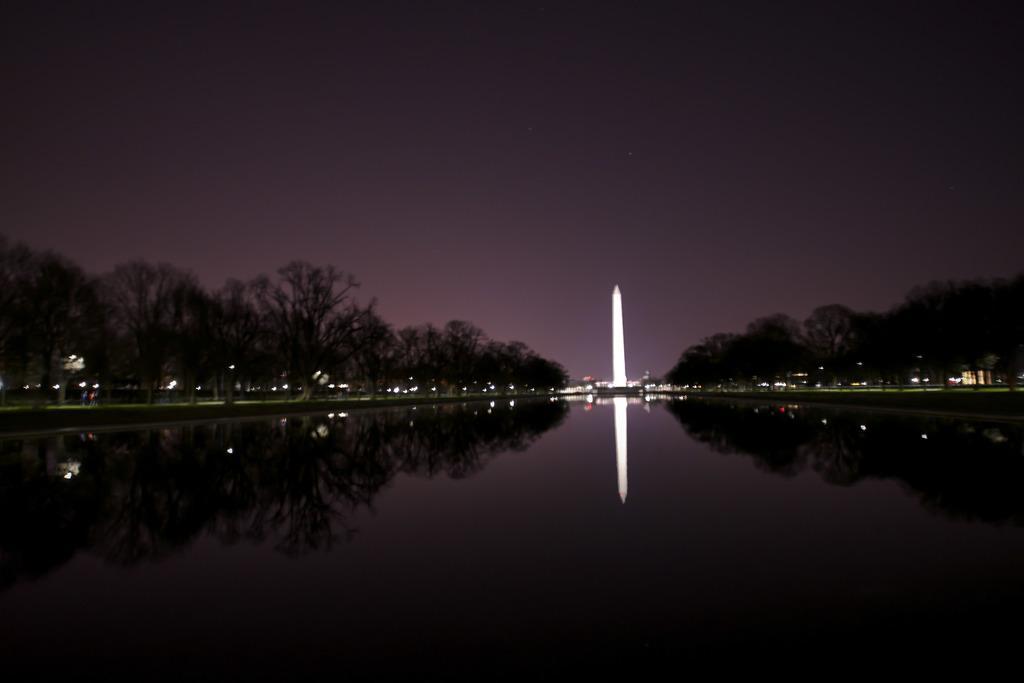Describe this image in one or two sentences. In the center of the image there is water. In the background of the image there is tower. There are trees. At the top of the image there is sky. 